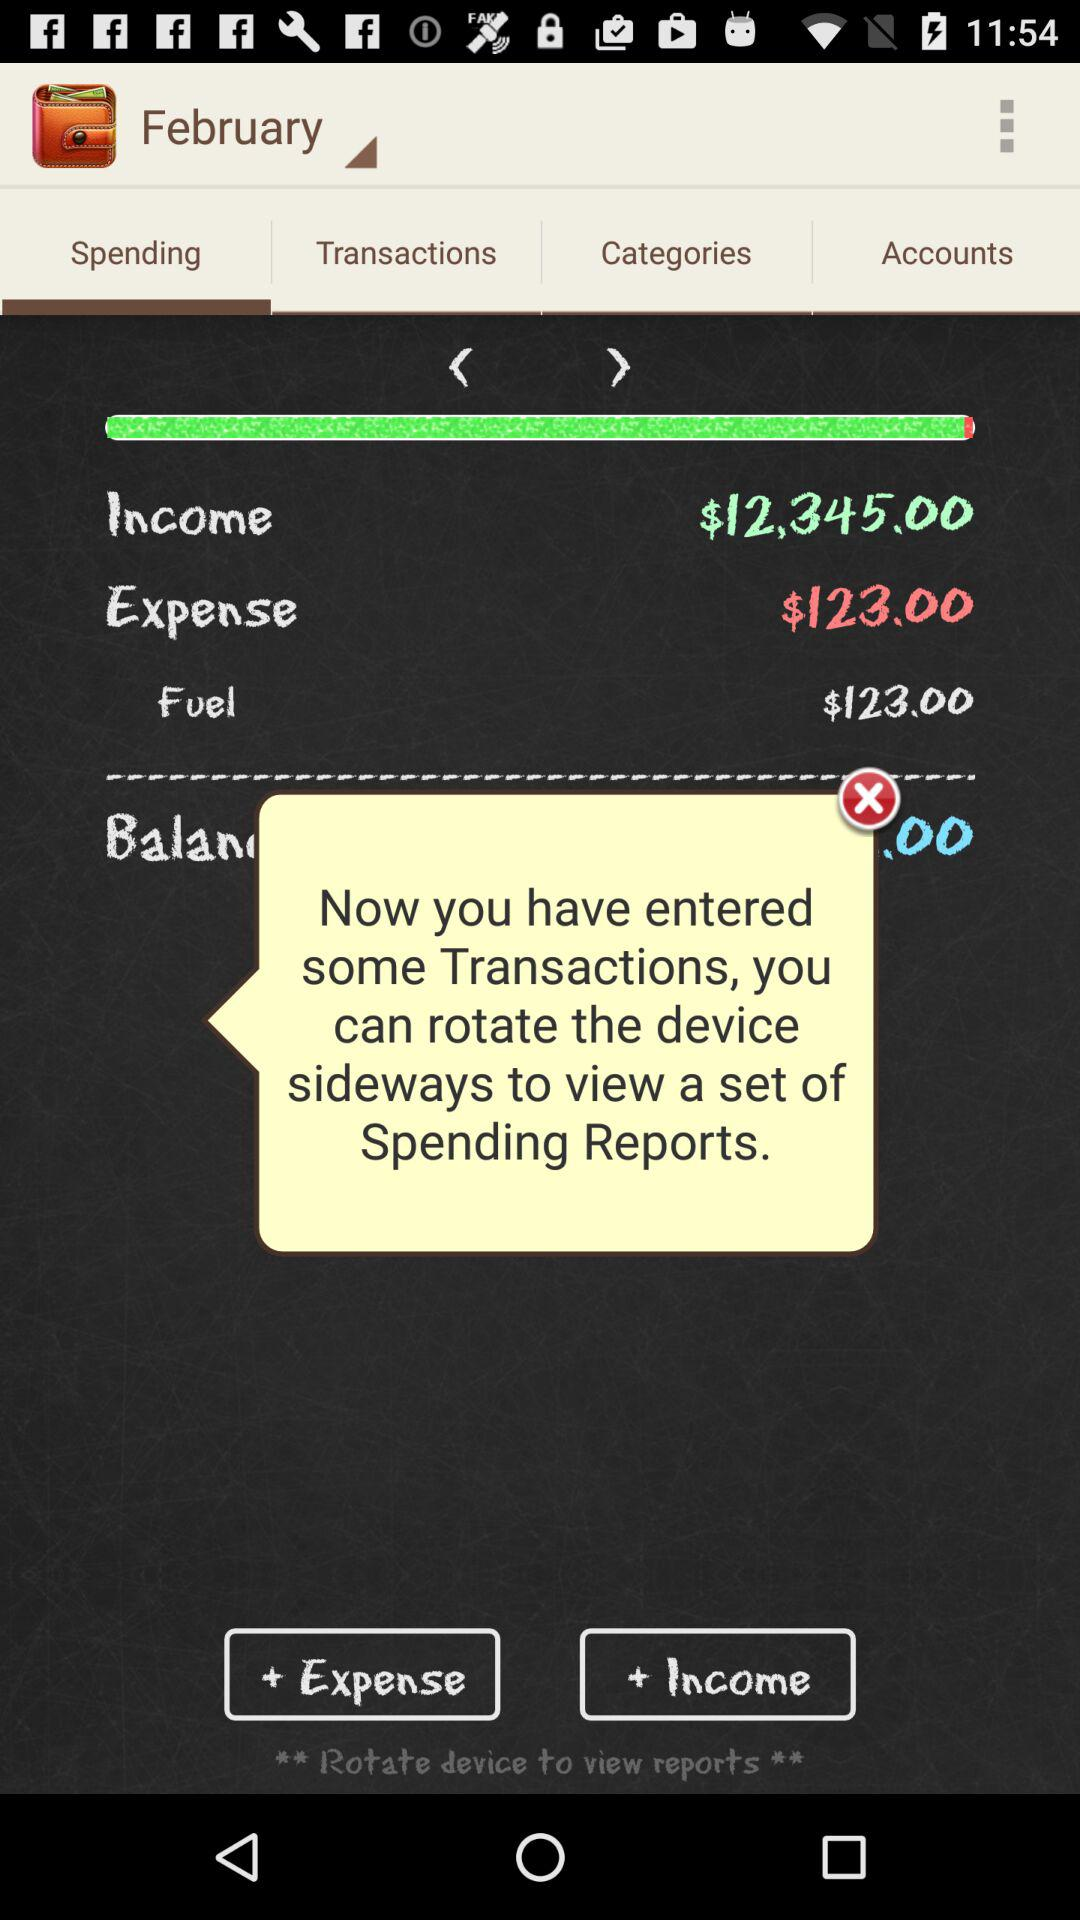What is the expense amount? The expense amount is $123. 